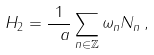<formula> <loc_0><loc_0><loc_500><loc_500>H _ { 2 } = \frac { 1 } { \ a } \sum _ { n \in \mathbb { Z } } \omega _ { n } N _ { n } \, ,</formula> 